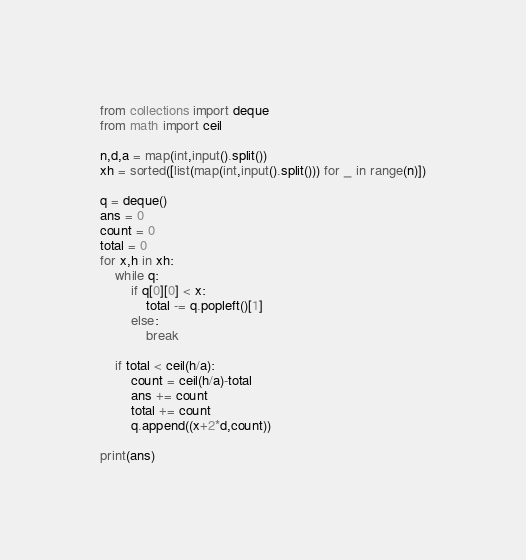Convert code to text. <code><loc_0><loc_0><loc_500><loc_500><_Python_>from collections import deque
from math import ceil

n,d,a = map(int,input().split())
xh = sorted([list(map(int,input().split())) for _ in range(n)])

q = deque()
ans = 0
count = 0
total = 0
for x,h in xh:
    while q:
        if q[0][0] < x:
            total -= q.popleft()[1]
        else:
            break
    
    if total < ceil(h/a):
        count = ceil(h/a)-total
        ans += count
        total += count
        q.append((x+2*d,count))

print(ans)</code> 